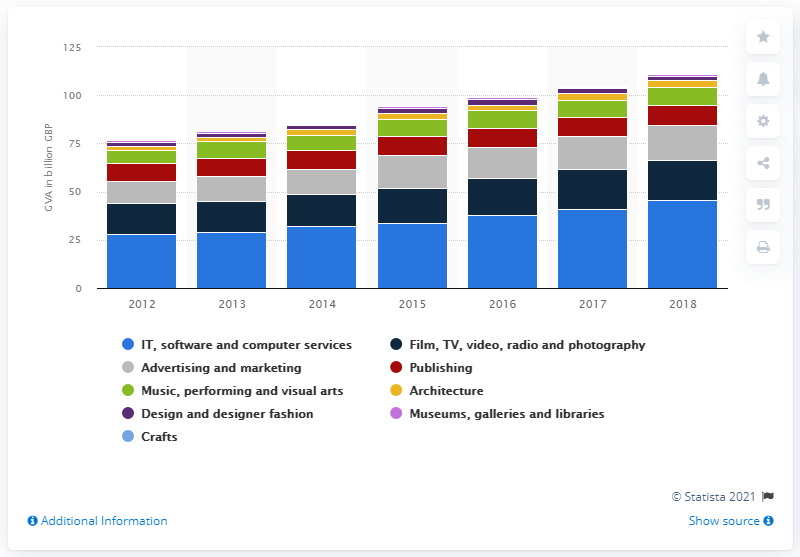Give some essential details in this illustration. In 2018, the gross value added of the advertising and marketing industry was 18.6 billion. 